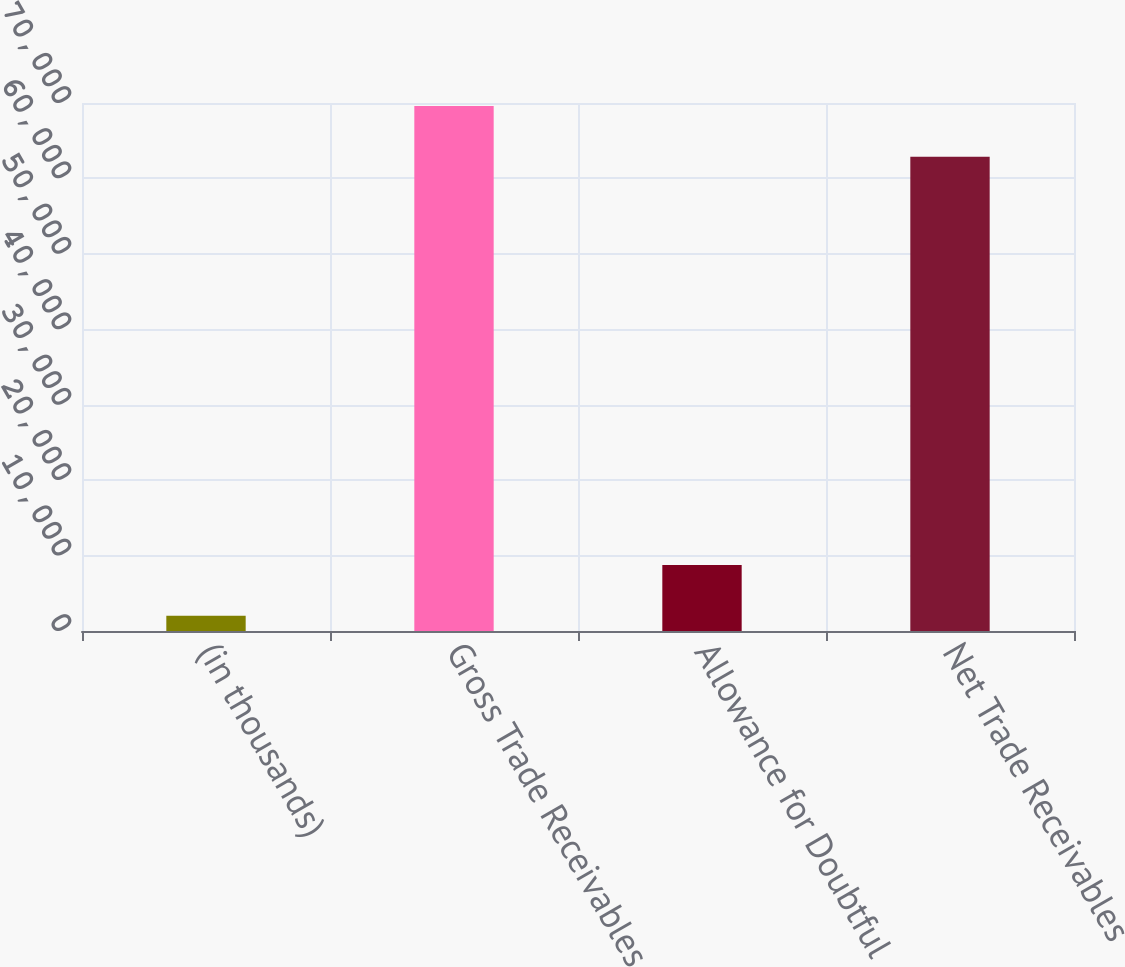Convert chart to OTSL. <chart><loc_0><loc_0><loc_500><loc_500><bar_chart><fcel>(in thousands)<fcel>Gross Trade Receivables<fcel>Allowance for Doubtful<fcel>Net Trade Receivables<nl><fcel>2007<fcel>69618.7<fcel>8759.7<fcel>62866<nl></chart> 